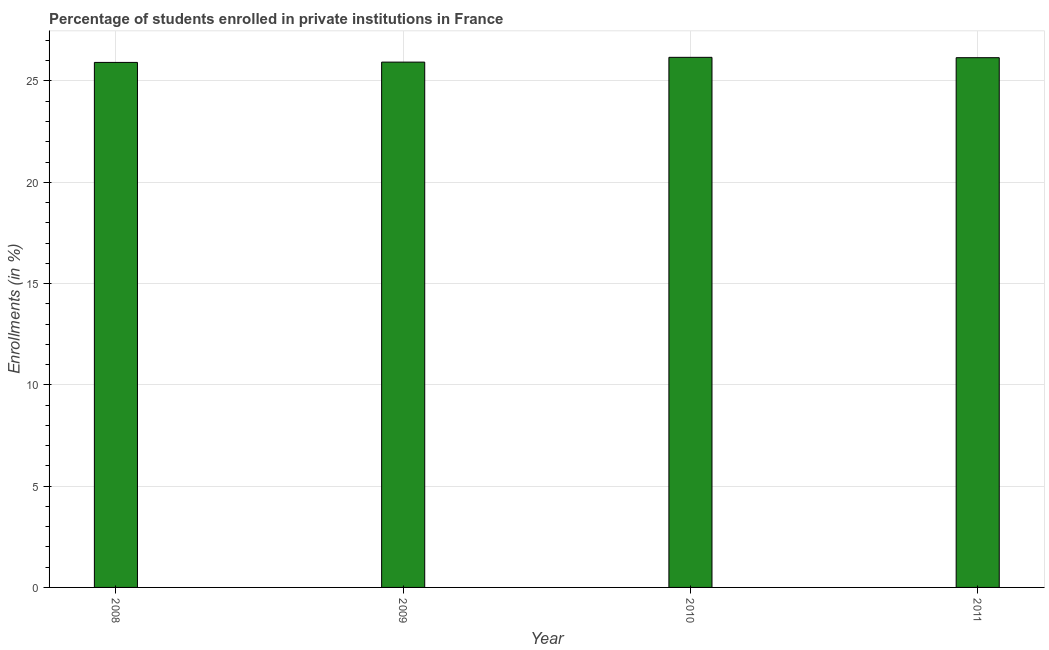Does the graph contain grids?
Give a very brief answer. Yes. What is the title of the graph?
Your answer should be very brief. Percentage of students enrolled in private institutions in France. What is the label or title of the Y-axis?
Offer a terse response. Enrollments (in %). What is the enrollments in private institutions in 2010?
Keep it short and to the point. 26.17. Across all years, what is the maximum enrollments in private institutions?
Your response must be concise. 26.17. Across all years, what is the minimum enrollments in private institutions?
Keep it short and to the point. 25.92. What is the sum of the enrollments in private institutions?
Provide a short and direct response. 104.17. What is the difference between the enrollments in private institutions in 2009 and 2011?
Your response must be concise. -0.22. What is the average enrollments in private institutions per year?
Offer a terse response. 26.04. What is the median enrollments in private institutions?
Your response must be concise. 26.04. In how many years, is the enrollments in private institutions greater than 25 %?
Your answer should be very brief. 4. Do a majority of the years between 2009 and 2011 (inclusive) have enrollments in private institutions greater than 14 %?
Give a very brief answer. Yes. Is the enrollments in private institutions in 2008 less than that in 2009?
Make the answer very short. Yes. What is the difference between the highest and the second highest enrollments in private institutions?
Your answer should be compact. 0.02. How many bars are there?
Your response must be concise. 4. What is the Enrollments (in %) of 2008?
Give a very brief answer. 25.92. What is the Enrollments (in %) in 2009?
Your answer should be very brief. 25.93. What is the Enrollments (in %) of 2010?
Make the answer very short. 26.17. What is the Enrollments (in %) of 2011?
Provide a succinct answer. 26.15. What is the difference between the Enrollments (in %) in 2008 and 2009?
Your answer should be compact. -0.01. What is the difference between the Enrollments (in %) in 2008 and 2010?
Give a very brief answer. -0.25. What is the difference between the Enrollments (in %) in 2008 and 2011?
Keep it short and to the point. -0.23. What is the difference between the Enrollments (in %) in 2009 and 2010?
Your response must be concise. -0.24. What is the difference between the Enrollments (in %) in 2009 and 2011?
Your answer should be compact. -0.22. What is the difference between the Enrollments (in %) in 2010 and 2011?
Your answer should be compact. 0.02. What is the ratio of the Enrollments (in %) in 2008 to that in 2010?
Your response must be concise. 0.99. What is the ratio of the Enrollments (in %) in 2009 to that in 2011?
Provide a short and direct response. 0.99. 